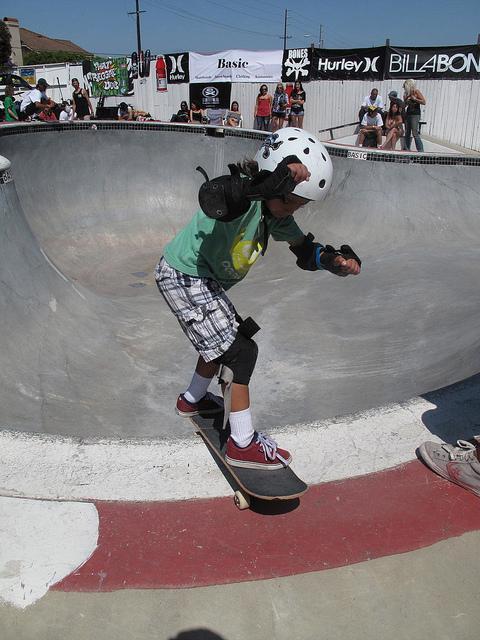How many people are there?
Give a very brief answer. 2. How many legs does the giraffe have?
Give a very brief answer. 0. 